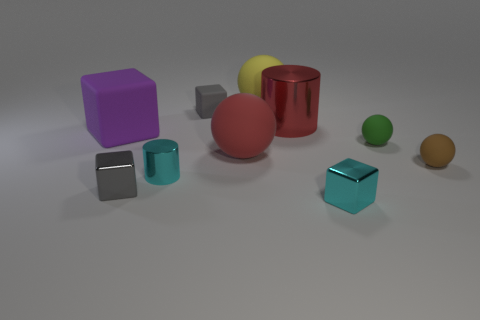What number of things are large balls that are behind the big metal cylinder or small brown matte spheres?
Provide a short and direct response. 2. There is a big rubber thing that is to the left of the small gray rubber object; what number of large matte cubes are in front of it?
Ensure brevity in your answer.  0. There is a metal cube that is left of the tiny cube that is on the right side of the gray thing behind the brown rubber thing; what size is it?
Your answer should be very brief. Small. Does the small object that is behind the large purple cube have the same color as the large metal cylinder?
Provide a short and direct response. No. What size is the other cyan thing that is the same shape as the big metallic object?
Make the answer very short. Small. What number of objects are either rubber objects in front of the small matte block or big things in front of the small gray matte block?
Make the answer very short. 5. There is a metallic object behind the large sphere that is in front of the small green rubber ball; what shape is it?
Your answer should be compact. Cylinder. Are there any other things of the same color as the large cylinder?
Your answer should be very brief. Yes. Are there any other things that have the same size as the cyan cube?
Your answer should be very brief. Yes. What number of things are either big yellow balls or large balls?
Ensure brevity in your answer.  2. 